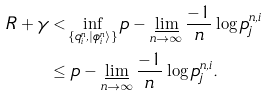Convert formula to latex. <formula><loc_0><loc_0><loc_500><loc_500>R + \gamma & < \inf _ { \{ q _ { i } ^ { n } , \left | \phi _ { i } ^ { n } \right \rangle \} } p - \varliminf _ { n \rightarrow \infty } \frac { - 1 } { n } \log p _ { j } ^ { n , i } \\ & \leq p - \varliminf _ { n \rightarrow \infty } \frac { - 1 } { n } \log p _ { j } ^ { n , i } .</formula> 